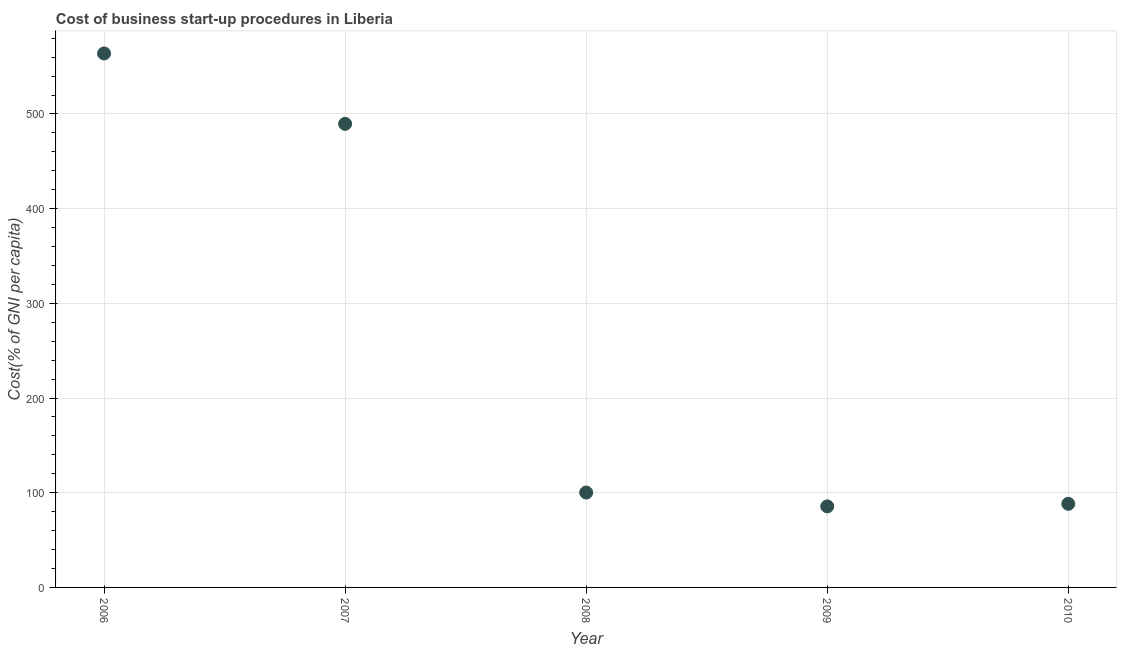What is the cost of business startup procedures in 2010?
Make the answer very short. 88.3. Across all years, what is the maximum cost of business startup procedures?
Your response must be concise. 563.9. Across all years, what is the minimum cost of business startup procedures?
Provide a short and direct response. 85.6. In which year was the cost of business startup procedures minimum?
Your response must be concise. 2009. What is the sum of the cost of business startup procedures?
Offer a terse response. 1327.6. What is the difference between the cost of business startup procedures in 2007 and 2008?
Provide a succinct answer. 389.4. What is the average cost of business startup procedures per year?
Offer a very short reply. 265.52. What is the median cost of business startup procedures?
Your answer should be compact. 100.2. What is the ratio of the cost of business startup procedures in 2007 to that in 2009?
Provide a succinct answer. 5.72. Is the cost of business startup procedures in 2007 less than that in 2010?
Your answer should be very brief. No. Is the difference between the cost of business startup procedures in 2006 and 2010 greater than the difference between any two years?
Provide a succinct answer. No. What is the difference between the highest and the second highest cost of business startup procedures?
Keep it short and to the point. 74.3. Is the sum of the cost of business startup procedures in 2009 and 2010 greater than the maximum cost of business startup procedures across all years?
Your answer should be compact. No. What is the difference between the highest and the lowest cost of business startup procedures?
Ensure brevity in your answer.  478.3. In how many years, is the cost of business startup procedures greater than the average cost of business startup procedures taken over all years?
Keep it short and to the point. 2. How many years are there in the graph?
Give a very brief answer. 5. What is the difference between two consecutive major ticks on the Y-axis?
Offer a terse response. 100. Does the graph contain any zero values?
Give a very brief answer. No. What is the title of the graph?
Your answer should be compact. Cost of business start-up procedures in Liberia. What is the label or title of the X-axis?
Offer a very short reply. Year. What is the label or title of the Y-axis?
Ensure brevity in your answer.  Cost(% of GNI per capita). What is the Cost(% of GNI per capita) in 2006?
Keep it short and to the point. 563.9. What is the Cost(% of GNI per capita) in 2007?
Keep it short and to the point. 489.6. What is the Cost(% of GNI per capita) in 2008?
Your response must be concise. 100.2. What is the Cost(% of GNI per capita) in 2009?
Your response must be concise. 85.6. What is the Cost(% of GNI per capita) in 2010?
Offer a very short reply. 88.3. What is the difference between the Cost(% of GNI per capita) in 2006 and 2007?
Provide a short and direct response. 74.3. What is the difference between the Cost(% of GNI per capita) in 2006 and 2008?
Your response must be concise. 463.7. What is the difference between the Cost(% of GNI per capita) in 2006 and 2009?
Provide a succinct answer. 478.3. What is the difference between the Cost(% of GNI per capita) in 2006 and 2010?
Your response must be concise. 475.6. What is the difference between the Cost(% of GNI per capita) in 2007 and 2008?
Provide a short and direct response. 389.4. What is the difference between the Cost(% of GNI per capita) in 2007 and 2009?
Give a very brief answer. 404. What is the difference between the Cost(% of GNI per capita) in 2007 and 2010?
Your answer should be very brief. 401.3. What is the difference between the Cost(% of GNI per capita) in 2008 and 2009?
Offer a terse response. 14.6. What is the difference between the Cost(% of GNI per capita) in 2009 and 2010?
Give a very brief answer. -2.7. What is the ratio of the Cost(% of GNI per capita) in 2006 to that in 2007?
Make the answer very short. 1.15. What is the ratio of the Cost(% of GNI per capita) in 2006 to that in 2008?
Your answer should be compact. 5.63. What is the ratio of the Cost(% of GNI per capita) in 2006 to that in 2009?
Give a very brief answer. 6.59. What is the ratio of the Cost(% of GNI per capita) in 2006 to that in 2010?
Give a very brief answer. 6.39. What is the ratio of the Cost(% of GNI per capita) in 2007 to that in 2008?
Offer a terse response. 4.89. What is the ratio of the Cost(% of GNI per capita) in 2007 to that in 2009?
Your response must be concise. 5.72. What is the ratio of the Cost(% of GNI per capita) in 2007 to that in 2010?
Ensure brevity in your answer.  5.54. What is the ratio of the Cost(% of GNI per capita) in 2008 to that in 2009?
Offer a terse response. 1.17. What is the ratio of the Cost(% of GNI per capita) in 2008 to that in 2010?
Ensure brevity in your answer.  1.14. 